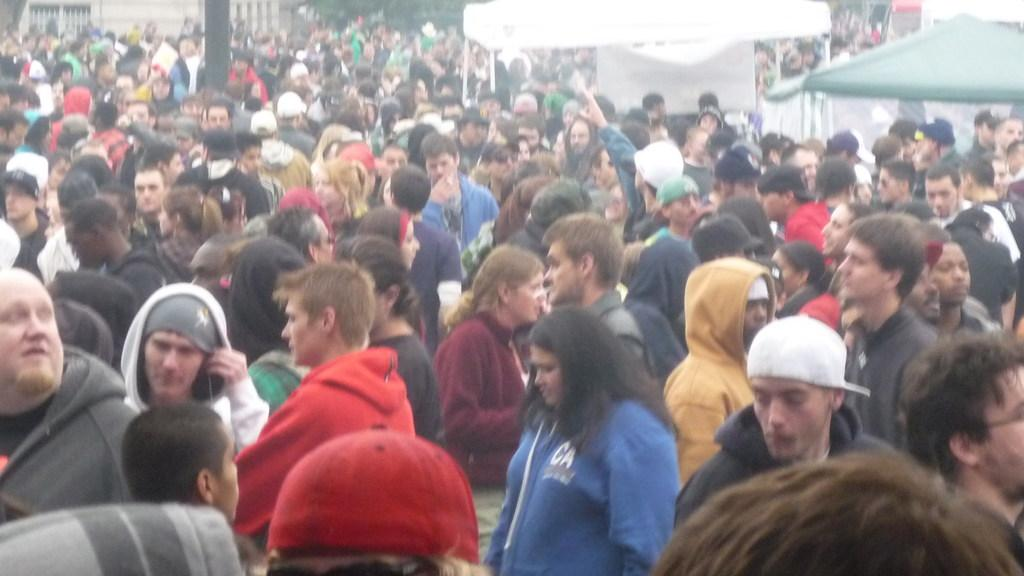What is the main feature of the image? The main feature of the image is a huge crowd. Where is the shelter located in relation to the crowd? The shelter is located on the right side of the image, between the crowd and a white color roof. What can be inferred about the size of the crowd from the image? The crowd appears to be large, as it is described as "huge." What type of flesh can be seen on the horns of the animals in the image? There are no animals or horns present in the image; it features a huge crowd and a shelter. 